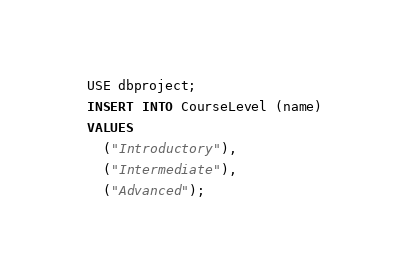Convert code to text. <code><loc_0><loc_0><loc_500><loc_500><_SQL_>USE dbproject;
INSERT INTO CourseLevel (name)
VALUES
  ("Introductory"),
  ("Intermediate"),
  ("Advanced");</code> 